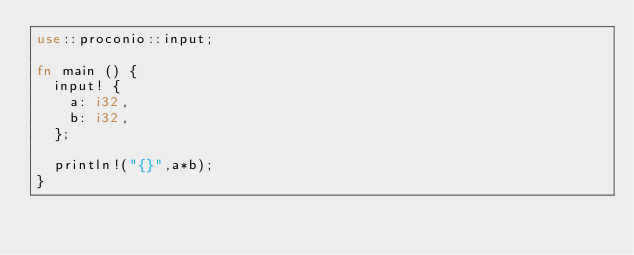<code> <loc_0><loc_0><loc_500><loc_500><_Rust_>use::proconio::input;

fn main () {
  input! {
    a: i32,
    b: i32,
  };
  
  println!("{}",a*b);
}</code> 